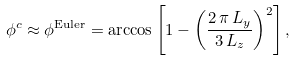<formula> <loc_0><loc_0><loc_500><loc_500>\phi ^ { c } \approx \phi ^ { \text {Euler} } = \arccos \left [ 1 - \left ( \frac { 2 \, \pi \, L _ { y } } { 3 \, L _ { z } } \right ) ^ { 2 } \right ] ,</formula> 